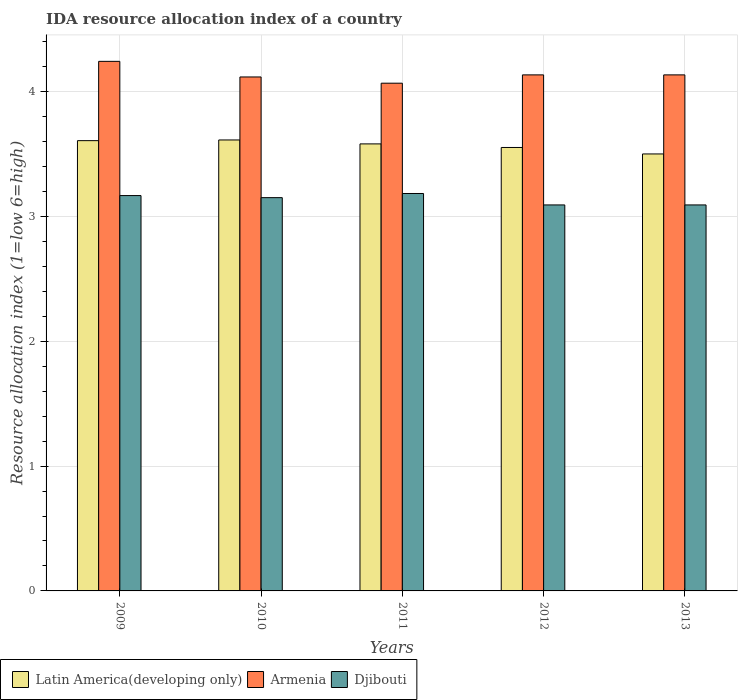How many different coloured bars are there?
Keep it short and to the point. 3. How many groups of bars are there?
Keep it short and to the point. 5. Are the number of bars per tick equal to the number of legend labels?
Provide a short and direct response. Yes. What is the label of the 3rd group of bars from the left?
Offer a very short reply. 2011. What is the IDA resource allocation index in Armenia in 2011?
Give a very brief answer. 4.07. Across all years, what is the maximum IDA resource allocation index in Latin America(developing only)?
Offer a very short reply. 3.61. Across all years, what is the minimum IDA resource allocation index in Armenia?
Provide a short and direct response. 4.07. In which year was the IDA resource allocation index in Armenia maximum?
Ensure brevity in your answer.  2009. In which year was the IDA resource allocation index in Djibouti minimum?
Provide a succinct answer. 2012. What is the total IDA resource allocation index in Djibouti in the graph?
Provide a succinct answer. 15.68. What is the difference between the IDA resource allocation index in Armenia in 2009 and that in 2013?
Make the answer very short. 0.11. What is the difference between the IDA resource allocation index in Djibouti in 2010 and the IDA resource allocation index in Latin America(developing only) in 2009?
Offer a terse response. -0.46. What is the average IDA resource allocation index in Armenia per year?
Make the answer very short. 4.14. In the year 2009, what is the difference between the IDA resource allocation index in Djibouti and IDA resource allocation index in Armenia?
Offer a very short reply. -1.07. What is the ratio of the IDA resource allocation index in Armenia in 2009 to that in 2013?
Your answer should be compact. 1.03. Is the difference between the IDA resource allocation index in Djibouti in 2009 and 2010 greater than the difference between the IDA resource allocation index in Armenia in 2009 and 2010?
Provide a short and direct response. No. What is the difference between the highest and the second highest IDA resource allocation index in Armenia?
Provide a succinct answer. 0.11. What is the difference between the highest and the lowest IDA resource allocation index in Armenia?
Provide a short and direct response. 0.17. In how many years, is the IDA resource allocation index in Latin America(developing only) greater than the average IDA resource allocation index in Latin America(developing only) taken over all years?
Keep it short and to the point. 3. What does the 2nd bar from the left in 2011 represents?
Provide a short and direct response. Armenia. What does the 1st bar from the right in 2010 represents?
Offer a very short reply. Djibouti. How many bars are there?
Offer a terse response. 15. Where does the legend appear in the graph?
Your response must be concise. Bottom left. How many legend labels are there?
Make the answer very short. 3. How are the legend labels stacked?
Ensure brevity in your answer.  Horizontal. What is the title of the graph?
Give a very brief answer. IDA resource allocation index of a country. What is the label or title of the Y-axis?
Ensure brevity in your answer.  Resource allocation index (1=low 6=high). What is the Resource allocation index (1=low 6=high) of Latin America(developing only) in 2009?
Provide a short and direct response. 3.61. What is the Resource allocation index (1=low 6=high) in Armenia in 2009?
Offer a very short reply. 4.24. What is the Resource allocation index (1=low 6=high) in Djibouti in 2009?
Your answer should be very brief. 3.17. What is the Resource allocation index (1=low 6=high) in Latin America(developing only) in 2010?
Offer a very short reply. 3.61. What is the Resource allocation index (1=low 6=high) of Armenia in 2010?
Make the answer very short. 4.12. What is the Resource allocation index (1=low 6=high) in Djibouti in 2010?
Your answer should be compact. 3.15. What is the Resource allocation index (1=low 6=high) in Latin America(developing only) in 2011?
Your answer should be very brief. 3.58. What is the Resource allocation index (1=low 6=high) of Armenia in 2011?
Offer a terse response. 4.07. What is the Resource allocation index (1=low 6=high) in Djibouti in 2011?
Your response must be concise. 3.18. What is the Resource allocation index (1=low 6=high) in Latin America(developing only) in 2012?
Your answer should be compact. 3.55. What is the Resource allocation index (1=low 6=high) of Armenia in 2012?
Your response must be concise. 4.13. What is the Resource allocation index (1=low 6=high) in Djibouti in 2012?
Your response must be concise. 3.09. What is the Resource allocation index (1=low 6=high) in Latin America(developing only) in 2013?
Give a very brief answer. 3.5. What is the Resource allocation index (1=low 6=high) in Armenia in 2013?
Make the answer very short. 4.13. What is the Resource allocation index (1=low 6=high) of Djibouti in 2013?
Offer a very short reply. 3.09. Across all years, what is the maximum Resource allocation index (1=low 6=high) of Latin America(developing only)?
Provide a short and direct response. 3.61. Across all years, what is the maximum Resource allocation index (1=low 6=high) in Armenia?
Provide a short and direct response. 4.24. Across all years, what is the maximum Resource allocation index (1=low 6=high) of Djibouti?
Your answer should be very brief. 3.18. Across all years, what is the minimum Resource allocation index (1=low 6=high) of Latin America(developing only)?
Your answer should be compact. 3.5. Across all years, what is the minimum Resource allocation index (1=low 6=high) of Armenia?
Provide a succinct answer. 4.07. Across all years, what is the minimum Resource allocation index (1=low 6=high) of Djibouti?
Your answer should be compact. 3.09. What is the total Resource allocation index (1=low 6=high) in Latin America(developing only) in the graph?
Your answer should be very brief. 17.85. What is the total Resource allocation index (1=low 6=high) in Armenia in the graph?
Your answer should be compact. 20.69. What is the total Resource allocation index (1=low 6=high) of Djibouti in the graph?
Ensure brevity in your answer.  15.68. What is the difference between the Resource allocation index (1=low 6=high) of Latin America(developing only) in 2009 and that in 2010?
Keep it short and to the point. -0.01. What is the difference between the Resource allocation index (1=low 6=high) in Djibouti in 2009 and that in 2010?
Your answer should be very brief. 0.02. What is the difference between the Resource allocation index (1=low 6=high) of Latin America(developing only) in 2009 and that in 2011?
Keep it short and to the point. 0.03. What is the difference between the Resource allocation index (1=low 6=high) of Armenia in 2009 and that in 2011?
Provide a short and direct response. 0.17. What is the difference between the Resource allocation index (1=low 6=high) in Djibouti in 2009 and that in 2011?
Your answer should be compact. -0.02. What is the difference between the Resource allocation index (1=low 6=high) in Latin America(developing only) in 2009 and that in 2012?
Your response must be concise. 0.05. What is the difference between the Resource allocation index (1=low 6=high) of Armenia in 2009 and that in 2012?
Your answer should be very brief. 0.11. What is the difference between the Resource allocation index (1=low 6=high) in Djibouti in 2009 and that in 2012?
Your answer should be compact. 0.07. What is the difference between the Resource allocation index (1=low 6=high) in Latin America(developing only) in 2009 and that in 2013?
Offer a terse response. 0.11. What is the difference between the Resource allocation index (1=low 6=high) of Armenia in 2009 and that in 2013?
Make the answer very short. 0.11. What is the difference between the Resource allocation index (1=low 6=high) of Djibouti in 2009 and that in 2013?
Provide a succinct answer. 0.07. What is the difference between the Resource allocation index (1=low 6=high) in Latin America(developing only) in 2010 and that in 2011?
Keep it short and to the point. 0.03. What is the difference between the Resource allocation index (1=low 6=high) in Armenia in 2010 and that in 2011?
Give a very brief answer. 0.05. What is the difference between the Resource allocation index (1=low 6=high) in Djibouti in 2010 and that in 2011?
Your answer should be very brief. -0.03. What is the difference between the Resource allocation index (1=low 6=high) of Latin America(developing only) in 2010 and that in 2012?
Provide a short and direct response. 0.06. What is the difference between the Resource allocation index (1=low 6=high) of Armenia in 2010 and that in 2012?
Offer a very short reply. -0.02. What is the difference between the Resource allocation index (1=low 6=high) in Djibouti in 2010 and that in 2012?
Ensure brevity in your answer.  0.06. What is the difference between the Resource allocation index (1=low 6=high) in Latin America(developing only) in 2010 and that in 2013?
Your answer should be compact. 0.11. What is the difference between the Resource allocation index (1=low 6=high) of Armenia in 2010 and that in 2013?
Offer a very short reply. -0.02. What is the difference between the Resource allocation index (1=low 6=high) in Djibouti in 2010 and that in 2013?
Your response must be concise. 0.06. What is the difference between the Resource allocation index (1=low 6=high) in Latin America(developing only) in 2011 and that in 2012?
Provide a succinct answer. 0.03. What is the difference between the Resource allocation index (1=low 6=high) of Armenia in 2011 and that in 2012?
Your answer should be very brief. -0.07. What is the difference between the Resource allocation index (1=low 6=high) in Djibouti in 2011 and that in 2012?
Provide a short and direct response. 0.09. What is the difference between the Resource allocation index (1=low 6=high) of Latin America(developing only) in 2011 and that in 2013?
Keep it short and to the point. 0.08. What is the difference between the Resource allocation index (1=low 6=high) in Armenia in 2011 and that in 2013?
Make the answer very short. -0.07. What is the difference between the Resource allocation index (1=low 6=high) of Djibouti in 2011 and that in 2013?
Offer a terse response. 0.09. What is the difference between the Resource allocation index (1=low 6=high) of Latin America(developing only) in 2012 and that in 2013?
Offer a terse response. 0.05. What is the difference between the Resource allocation index (1=low 6=high) of Armenia in 2012 and that in 2013?
Provide a succinct answer. 0. What is the difference between the Resource allocation index (1=low 6=high) of Djibouti in 2012 and that in 2013?
Your answer should be compact. 0. What is the difference between the Resource allocation index (1=low 6=high) in Latin America(developing only) in 2009 and the Resource allocation index (1=low 6=high) in Armenia in 2010?
Keep it short and to the point. -0.51. What is the difference between the Resource allocation index (1=low 6=high) of Latin America(developing only) in 2009 and the Resource allocation index (1=low 6=high) of Djibouti in 2010?
Provide a succinct answer. 0.46. What is the difference between the Resource allocation index (1=low 6=high) of Armenia in 2009 and the Resource allocation index (1=low 6=high) of Djibouti in 2010?
Keep it short and to the point. 1.09. What is the difference between the Resource allocation index (1=low 6=high) in Latin America(developing only) in 2009 and the Resource allocation index (1=low 6=high) in Armenia in 2011?
Your answer should be very brief. -0.46. What is the difference between the Resource allocation index (1=low 6=high) in Latin America(developing only) in 2009 and the Resource allocation index (1=low 6=high) in Djibouti in 2011?
Offer a very short reply. 0.42. What is the difference between the Resource allocation index (1=low 6=high) in Armenia in 2009 and the Resource allocation index (1=low 6=high) in Djibouti in 2011?
Your answer should be very brief. 1.06. What is the difference between the Resource allocation index (1=low 6=high) in Latin America(developing only) in 2009 and the Resource allocation index (1=low 6=high) in Armenia in 2012?
Provide a short and direct response. -0.53. What is the difference between the Resource allocation index (1=low 6=high) of Latin America(developing only) in 2009 and the Resource allocation index (1=low 6=high) of Djibouti in 2012?
Ensure brevity in your answer.  0.51. What is the difference between the Resource allocation index (1=low 6=high) in Armenia in 2009 and the Resource allocation index (1=low 6=high) in Djibouti in 2012?
Offer a very short reply. 1.15. What is the difference between the Resource allocation index (1=low 6=high) of Latin America(developing only) in 2009 and the Resource allocation index (1=low 6=high) of Armenia in 2013?
Provide a succinct answer. -0.53. What is the difference between the Resource allocation index (1=low 6=high) in Latin America(developing only) in 2009 and the Resource allocation index (1=low 6=high) in Djibouti in 2013?
Offer a very short reply. 0.51. What is the difference between the Resource allocation index (1=low 6=high) in Armenia in 2009 and the Resource allocation index (1=low 6=high) in Djibouti in 2013?
Provide a short and direct response. 1.15. What is the difference between the Resource allocation index (1=low 6=high) of Latin America(developing only) in 2010 and the Resource allocation index (1=low 6=high) of Armenia in 2011?
Your response must be concise. -0.45. What is the difference between the Resource allocation index (1=low 6=high) in Latin America(developing only) in 2010 and the Resource allocation index (1=low 6=high) in Djibouti in 2011?
Your response must be concise. 0.43. What is the difference between the Resource allocation index (1=low 6=high) in Armenia in 2010 and the Resource allocation index (1=low 6=high) in Djibouti in 2011?
Make the answer very short. 0.93. What is the difference between the Resource allocation index (1=low 6=high) in Latin America(developing only) in 2010 and the Resource allocation index (1=low 6=high) in Armenia in 2012?
Make the answer very short. -0.52. What is the difference between the Resource allocation index (1=low 6=high) in Latin America(developing only) in 2010 and the Resource allocation index (1=low 6=high) in Djibouti in 2012?
Your response must be concise. 0.52. What is the difference between the Resource allocation index (1=low 6=high) in Armenia in 2010 and the Resource allocation index (1=low 6=high) in Djibouti in 2012?
Your answer should be very brief. 1.02. What is the difference between the Resource allocation index (1=low 6=high) in Latin America(developing only) in 2010 and the Resource allocation index (1=low 6=high) in Armenia in 2013?
Offer a terse response. -0.52. What is the difference between the Resource allocation index (1=low 6=high) in Latin America(developing only) in 2010 and the Resource allocation index (1=low 6=high) in Djibouti in 2013?
Ensure brevity in your answer.  0.52. What is the difference between the Resource allocation index (1=low 6=high) of Armenia in 2010 and the Resource allocation index (1=low 6=high) of Djibouti in 2013?
Your answer should be very brief. 1.02. What is the difference between the Resource allocation index (1=low 6=high) in Latin America(developing only) in 2011 and the Resource allocation index (1=low 6=high) in Armenia in 2012?
Provide a short and direct response. -0.55. What is the difference between the Resource allocation index (1=low 6=high) in Latin America(developing only) in 2011 and the Resource allocation index (1=low 6=high) in Djibouti in 2012?
Offer a terse response. 0.49. What is the difference between the Resource allocation index (1=low 6=high) in Armenia in 2011 and the Resource allocation index (1=low 6=high) in Djibouti in 2012?
Give a very brief answer. 0.97. What is the difference between the Resource allocation index (1=low 6=high) of Latin America(developing only) in 2011 and the Resource allocation index (1=low 6=high) of Armenia in 2013?
Ensure brevity in your answer.  -0.55. What is the difference between the Resource allocation index (1=low 6=high) in Latin America(developing only) in 2011 and the Resource allocation index (1=low 6=high) in Djibouti in 2013?
Provide a short and direct response. 0.49. What is the difference between the Resource allocation index (1=low 6=high) of Latin America(developing only) in 2012 and the Resource allocation index (1=low 6=high) of Armenia in 2013?
Ensure brevity in your answer.  -0.58. What is the difference between the Resource allocation index (1=low 6=high) in Latin America(developing only) in 2012 and the Resource allocation index (1=low 6=high) in Djibouti in 2013?
Provide a succinct answer. 0.46. What is the difference between the Resource allocation index (1=low 6=high) in Armenia in 2012 and the Resource allocation index (1=low 6=high) in Djibouti in 2013?
Provide a short and direct response. 1.04. What is the average Resource allocation index (1=low 6=high) in Latin America(developing only) per year?
Make the answer very short. 3.57. What is the average Resource allocation index (1=low 6=high) of Armenia per year?
Give a very brief answer. 4.14. What is the average Resource allocation index (1=low 6=high) of Djibouti per year?
Offer a very short reply. 3.14. In the year 2009, what is the difference between the Resource allocation index (1=low 6=high) in Latin America(developing only) and Resource allocation index (1=low 6=high) in Armenia?
Provide a short and direct response. -0.64. In the year 2009, what is the difference between the Resource allocation index (1=low 6=high) of Latin America(developing only) and Resource allocation index (1=low 6=high) of Djibouti?
Make the answer very short. 0.44. In the year 2009, what is the difference between the Resource allocation index (1=low 6=high) in Armenia and Resource allocation index (1=low 6=high) in Djibouti?
Keep it short and to the point. 1.07. In the year 2010, what is the difference between the Resource allocation index (1=low 6=high) in Latin America(developing only) and Resource allocation index (1=low 6=high) in Armenia?
Make the answer very short. -0.5. In the year 2010, what is the difference between the Resource allocation index (1=low 6=high) of Latin America(developing only) and Resource allocation index (1=low 6=high) of Djibouti?
Provide a short and direct response. 0.46. In the year 2010, what is the difference between the Resource allocation index (1=low 6=high) in Armenia and Resource allocation index (1=low 6=high) in Djibouti?
Your response must be concise. 0.97. In the year 2011, what is the difference between the Resource allocation index (1=low 6=high) of Latin America(developing only) and Resource allocation index (1=low 6=high) of Armenia?
Make the answer very short. -0.49. In the year 2011, what is the difference between the Resource allocation index (1=low 6=high) in Latin America(developing only) and Resource allocation index (1=low 6=high) in Djibouti?
Your answer should be compact. 0.4. In the year 2011, what is the difference between the Resource allocation index (1=low 6=high) in Armenia and Resource allocation index (1=low 6=high) in Djibouti?
Your answer should be compact. 0.88. In the year 2012, what is the difference between the Resource allocation index (1=low 6=high) in Latin America(developing only) and Resource allocation index (1=low 6=high) in Armenia?
Keep it short and to the point. -0.58. In the year 2012, what is the difference between the Resource allocation index (1=low 6=high) in Latin America(developing only) and Resource allocation index (1=low 6=high) in Djibouti?
Offer a very short reply. 0.46. In the year 2012, what is the difference between the Resource allocation index (1=low 6=high) of Armenia and Resource allocation index (1=low 6=high) of Djibouti?
Your answer should be compact. 1.04. In the year 2013, what is the difference between the Resource allocation index (1=low 6=high) of Latin America(developing only) and Resource allocation index (1=low 6=high) of Armenia?
Keep it short and to the point. -0.63. In the year 2013, what is the difference between the Resource allocation index (1=low 6=high) in Latin America(developing only) and Resource allocation index (1=low 6=high) in Djibouti?
Ensure brevity in your answer.  0.41. In the year 2013, what is the difference between the Resource allocation index (1=low 6=high) of Armenia and Resource allocation index (1=low 6=high) of Djibouti?
Your answer should be very brief. 1.04. What is the ratio of the Resource allocation index (1=low 6=high) of Latin America(developing only) in 2009 to that in 2010?
Provide a short and direct response. 1. What is the ratio of the Resource allocation index (1=low 6=high) in Armenia in 2009 to that in 2010?
Provide a short and direct response. 1.03. What is the ratio of the Resource allocation index (1=low 6=high) in Armenia in 2009 to that in 2011?
Give a very brief answer. 1.04. What is the ratio of the Resource allocation index (1=low 6=high) of Djibouti in 2009 to that in 2011?
Give a very brief answer. 0.99. What is the ratio of the Resource allocation index (1=low 6=high) of Latin America(developing only) in 2009 to that in 2012?
Make the answer very short. 1.02. What is the ratio of the Resource allocation index (1=low 6=high) in Armenia in 2009 to that in 2012?
Provide a short and direct response. 1.03. What is the ratio of the Resource allocation index (1=low 6=high) in Djibouti in 2009 to that in 2012?
Make the answer very short. 1.02. What is the ratio of the Resource allocation index (1=low 6=high) in Latin America(developing only) in 2009 to that in 2013?
Offer a terse response. 1.03. What is the ratio of the Resource allocation index (1=low 6=high) of Armenia in 2009 to that in 2013?
Ensure brevity in your answer.  1.03. What is the ratio of the Resource allocation index (1=low 6=high) of Djibouti in 2009 to that in 2013?
Keep it short and to the point. 1.02. What is the ratio of the Resource allocation index (1=low 6=high) in Latin America(developing only) in 2010 to that in 2011?
Your answer should be very brief. 1.01. What is the ratio of the Resource allocation index (1=low 6=high) of Armenia in 2010 to that in 2011?
Your answer should be very brief. 1.01. What is the ratio of the Resource allocation index (1=low 6=high) of Latin America(developing only) in 2010 to that in 2012?
Keep it short and to the point. 1.02. What is the ratio of the Resource allocation index (1=low 6=high) of Djibouti in 2010 to that in 2012?
Provide a short and direct response. 1.02. What is the ratio of the Resource allocation index (1=low 6=high) in Latin America(developing only) in 2010 to that in 2013?
Your response must be concise. 1.03. What is the ratio of the Resource allocation index (1=low 6=high) of Armenia in 2010 to that in 2013?
Your answer should be very brief. 1. What is the ratio of the Resource allocation index (1=low 6=high) of Djibouti in 2010 to that in 2013?
Your answer should be very brief. 1.02. What is the ratio of the Resource allocation index (1=low 6=high) in Latin America(developing only) in 2011 to that in 2012?
Offer a terse response. 1.01. What is the ratio of the Resource allocation index (1=low 6=high) of Armenia in 2011 to that in 2012?
Make the answer very short. 0.98. What is the ratio of the Resource allocation index (1=low 6=high) of Djibouti in 2011 to that in 2012?
Ensure brevity in your answer.  1.03. What is the ratio of the Resource allocation index (1=low 6=high) of Latin America(developing only) in 2011 to that in 2013?
Keep it short and to the point. 1.02. What is the ratio of the Resource allocation index (1=low 6=high) of Armenia in 2011 to that in 2013?
Your answer should be compact. 0.98. What is the ratio of the Resource allocation index (1=low 6=high) in Djibouti in 2011 to that in 2013?
Provide a short and direct response. 1.03. What is the ratio of the Resource allocation index (1=low 6=high) in Latin America(developing only) in 2012 to that in 2013?
Ensure brevity in your answer.  1.01. What is the ratio of the Resource allocation index (1=low 6=high) in Armenia in 2012 to that in 2013?
Your response must be concise. 1. What is the ratio of the Resource allocation index (1=low 6=high) in Djibouti in 2012 to that in 2013?
Keep it short and to the point. 1. What is the difference between the highest and the second highest Resource allocation index (1=low 6=high) of Latin America(developing only)?
Ensure brevity in your answer.  0.01. What is the difference between the highest and the second highest Resource allocation index (1=low 6=high) in Armenia?
Your answer should be compact. 0.11. What is the difference between the highest and the second highest Resource allocation index (1=low 6=high) in Djibouti?
Your answer should be very brief. 0.02. What is the difference between the highest and the lowest Resource allocation index (1=low 6=high) in Latin America(developing only)?
Keep it short and to the point. 0.11. What is the difference between the highest and the lowest Resource allocation index (1=low 6=high) in Armenia?
Offer a very short reply. 0.17. What is the difference between the highest and the lowest Resource allocation index (1=low 6=high) of Djibouti?
Keep it short and to the point. 0.09. 